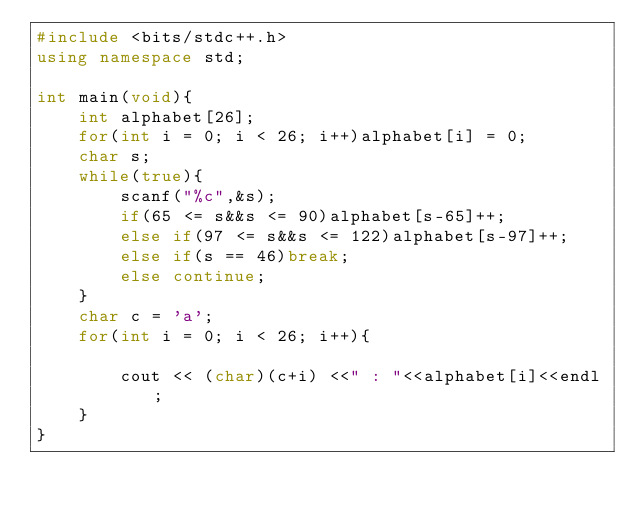Convert code to text. <code><loc_0><loc_0><loc_500><loc_500><_C++_>#include <bits/stdc++.h>
using namespace std;

int main(void){
	int alphabet[26];
	for(int i = 0; i < 26; i++)alphabet[i] = 0;
	char s;
	while(true){
		scanf("%c",&s);
		if(65 <= s&&s <= 90)alphabet[s-65]++;
		else if(97 <= s&&s <= 122)alphabet[s-97]++;
		else if(s == 46)break;
		else continue;
	}
	char c = 'a';
	for(int i = 0; i < 26; i++){
		
		cout << (char)(c+i) <<" : "<<alphabet[i]<<endl;
	}
}
</code> 